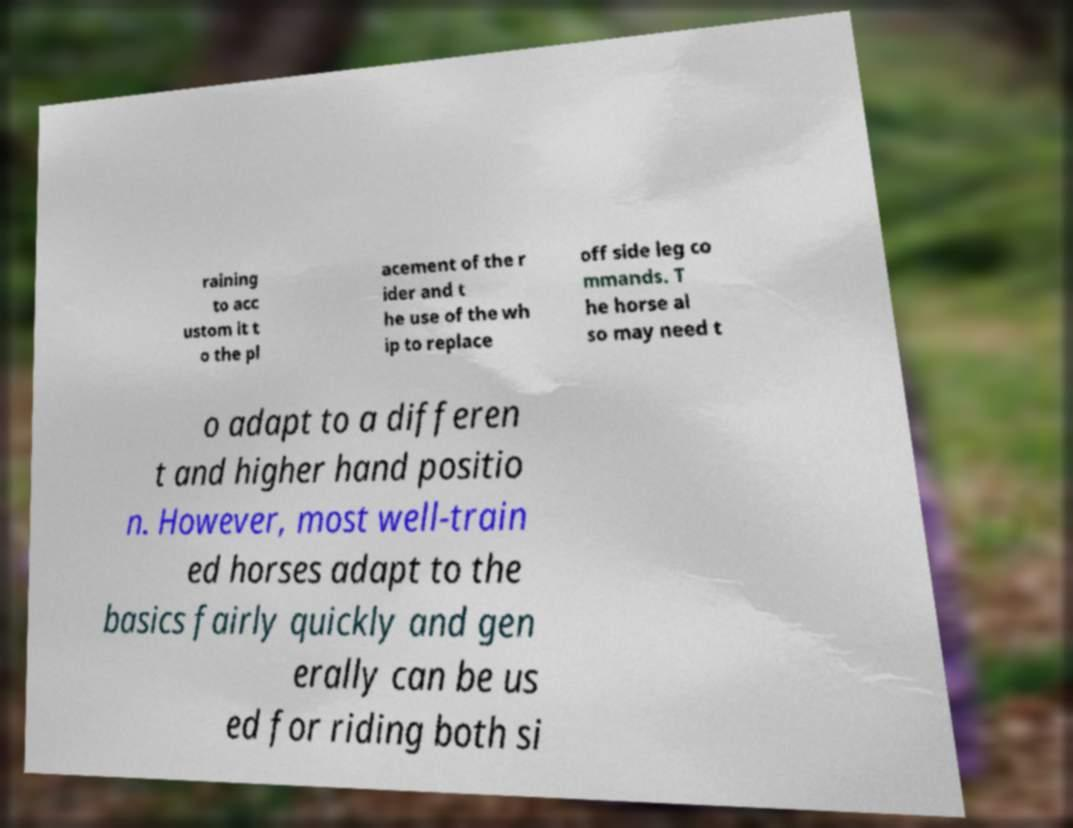Could you assist in decoding the text presented in this image and type it out clearly? raining to acc ustom it t o the pl acement of the r ider and t he use of the wh ip to replace off side leg co mmands. T he horse al so may need t o adapt to a differen t and higher hand positio n. However, most well-train ed horses adapt to the basics fairly quickly and gen erally can be us ed for riding both si 